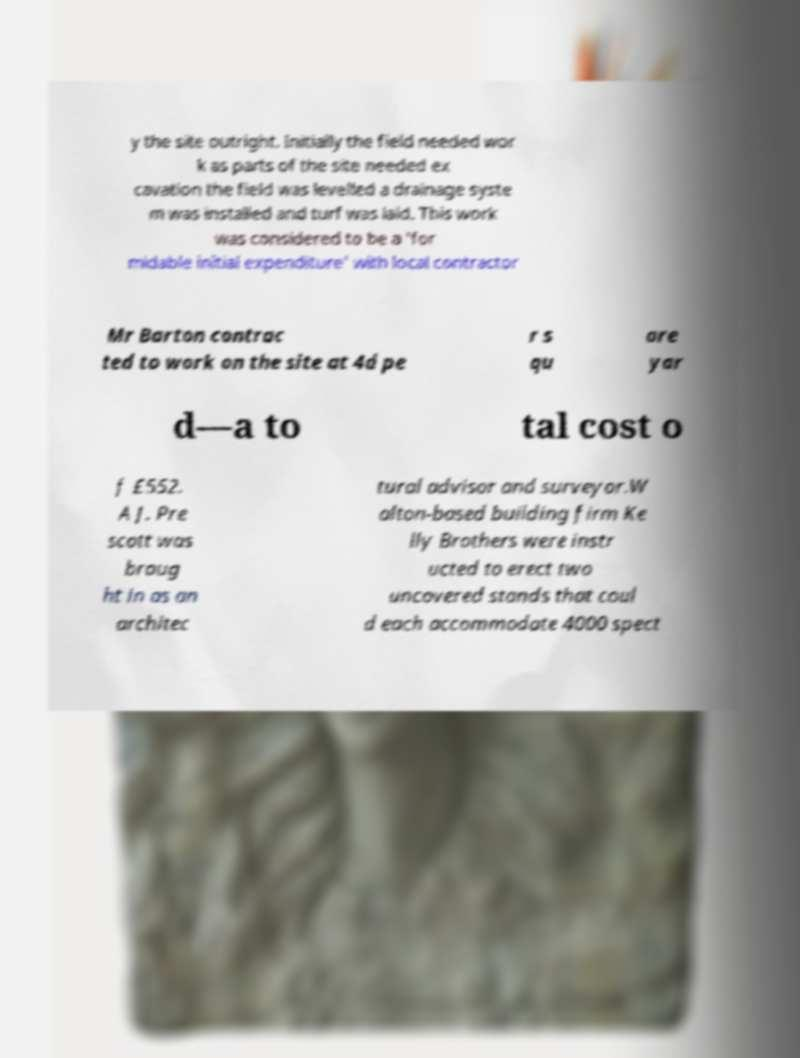There's text embedded in this image that I need extracted. Can you transcribe it verbatim? y the site outright. Initially the field needed wor k as parts of the site needed ex cavation the field was levelled a drainage syste m was installed and turf was laid. This work was considered to be a 'for midable initial expenditure' with local contractor Mr Barton contrac ted to work on the site at 4d pe r s qu are yar d—a to tal cost o f £552. A J. Pre scott was broug ht in as an architec tural advisor and surveyor.W alton-based building firm Ke lly Brothers were instr ucted to erect two uncovered stands that coul d each accommodate 4000 spect 